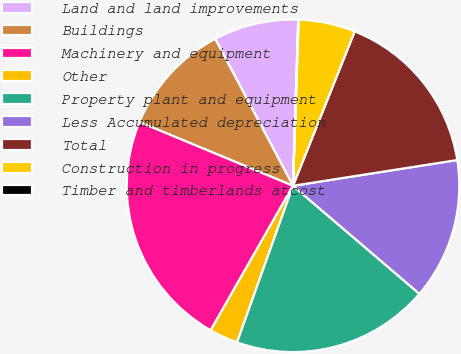<chart> <loc_0><loc_0><loc_500><loc_500><pie_chart><fcel>Land and land improvements<fcel>Buildings<fcel>Machinery and equipment<fcel>Other<fcel>Property plant and equipment<fcel>Less Accumulated depreciation<fcel>Total<fcel>Construction in progress<fcel>Timber and timberlands atcost<nl><fcel>8.25%<fcel>10.99%<fcel>23.01%<fcel>2.78%<fcel>19.21%<fcel>13.73%<fcel>16.47%<fcel>5.51%<fcel>0.04%<nl></chart> 